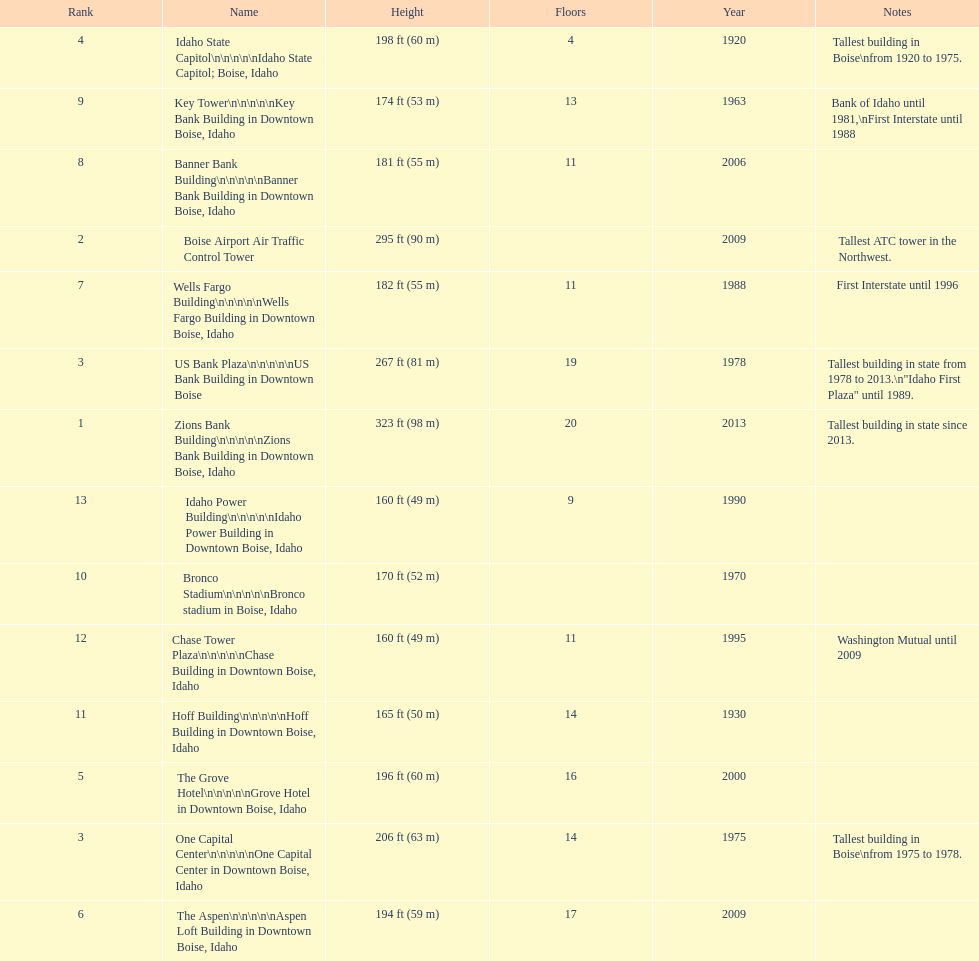What are the number of floors the us bank plaza has? 19. 